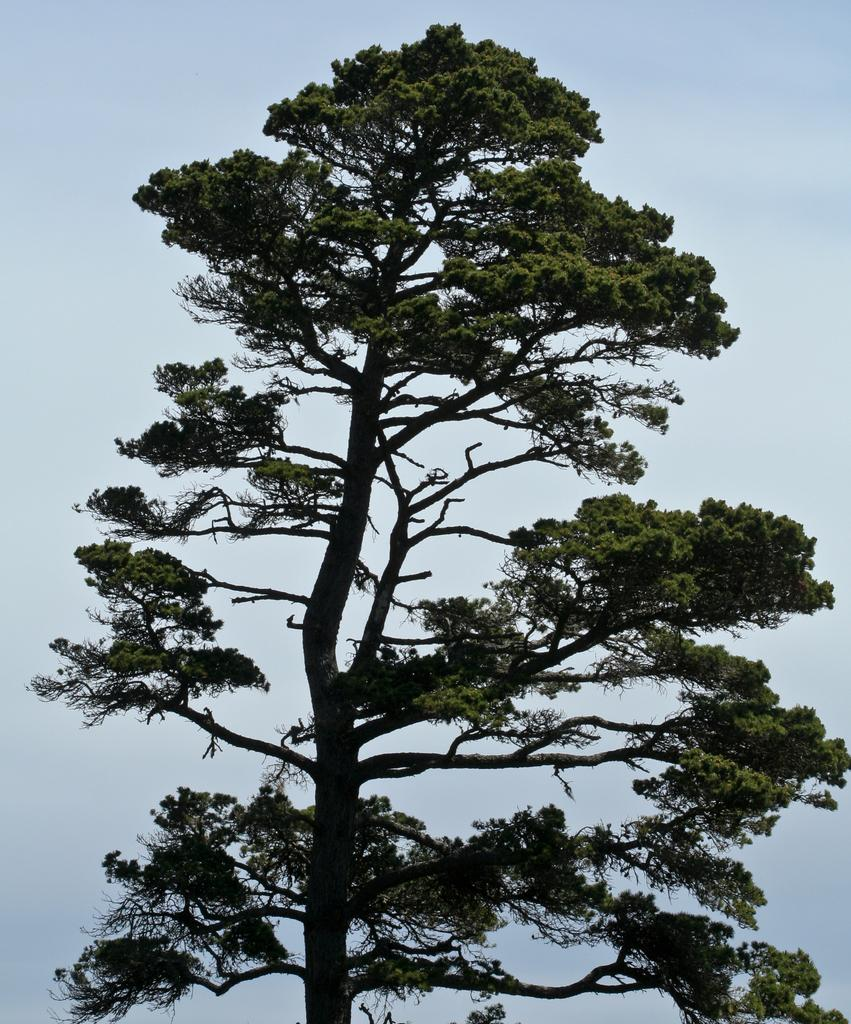What is the main subject in the center of the image? There is a tree in the center of the image. What can be seen in the background of the image? There is sky visible in the background of the image. What type of orange is being held by the person in jail in the image? There is no person or jail present in the image, and therefore no orange being held. 